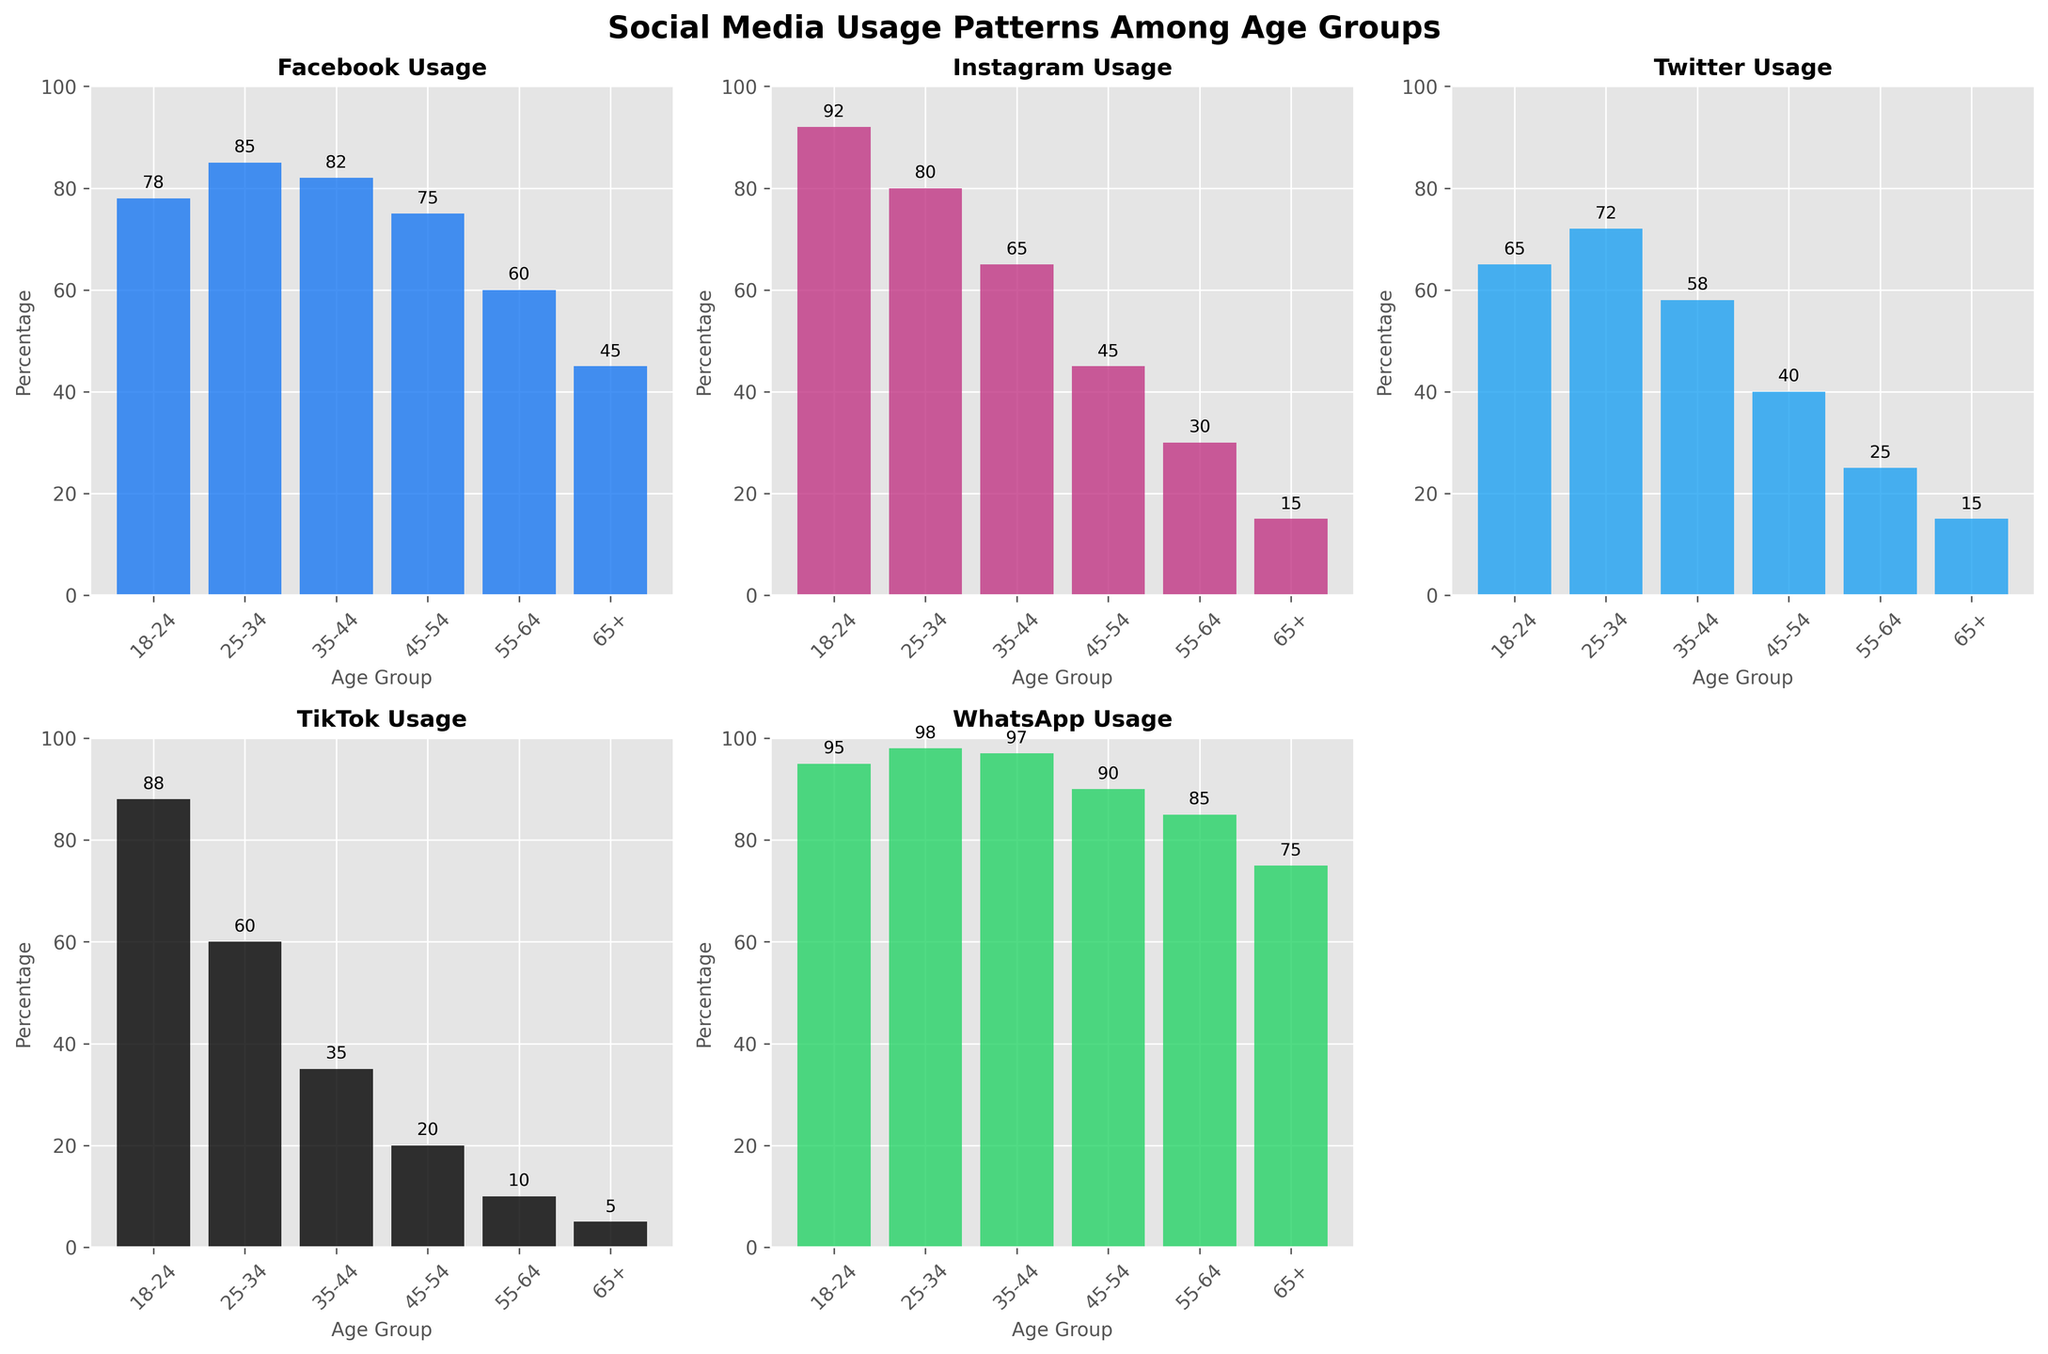Which age group has the highest Facebook usage? By looking at the Facebook subplot, we can see that the bar for the 25-34 age group is the tallest.
Answer: 25-34 Which platform has the highest usage percentage among the 18-24 age group? In the subplots, the 18-24 age group has the highest bar in the WhatsApp subplot, indicating the highest usage percentage.
Answer: WhatsApp What is the difference in Instagram usage between the 18-24 and 45-54 age groups? Referring to the Instagram subplot, the 18-24 age group has a usage percentage of 92, and the 45-54 age group has 45. The difference is 92 - 45 = 47.
Answer: 47 Which age group has the lowest TikTok usage? By examining the TikTok subplot, the 65+ age group has the smallest bar, indicating the lowest usage.
Answer: 65+ How does the Twitter usage in the 35-44 age group compare to the 55-64 age group? In the Twitter subplot, the 35-44 age group has a bar at 58, while the 55-64 age group has a bar at 25. Therefore, the 35-44 age group uses Twitter more.
Answer: Higher in 35-44 What is the average WhatsApp usage across all age groups? The WhatsApp usage percentages are 95, 98, 97, 90, 85, and 75. Sum these values: 95 + 98 + 97 + 90 + 85 + 75 = 540. The average is 540 / 6 = 90.
Answer: 90 Which age groups have a TikTok usage rate greater than 50%? By looking at the TikTok subplot, the 18-24 and 25-34 age groups have bars above the 50 mark.
Answer: 18-24, 25-34 What is the sum of Facebook and Instagram usage in the 25-34 age group? Referring to the Facebook and Instagram subplots, the 25-34 age group has usage percentages of 85 and 80 respectively. Summing these gives 85 + 80 = 165.
Answer: 165 Which age group shows a decrease in social media usage across all platforms except WhatsApp? Looking across all subplots, the 65+ age group consistently shows lower usage across all platforms except for WhatsApp when compared to younger age groups.
Answer: 65+ Which platform has the least variation in usage across different age groups? Examining all subplots, WhatsApp shows high and relatively stable usage across all age groups, indicating the least variation.
Answer: WhatsApp 